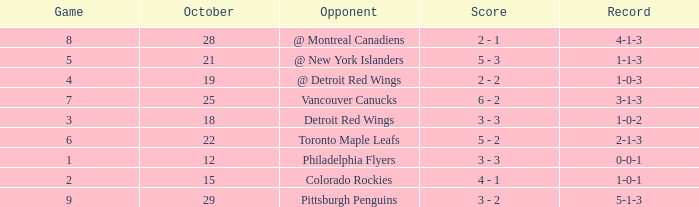Name the score for game more than 6 and before october 28 6 - 2. 